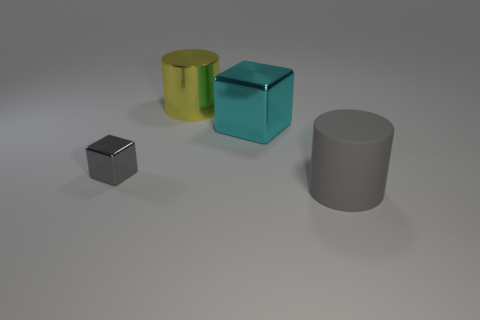Subtract all green blocks. Subtract all yellow cylinders. How many blocks are left? 2 Add 3 small purple metal spheres. How many objects exist? 7 Subtract 0 blue cylinders. How many objects are left? 4 Subtract all tiny metallic blocks. Subtract all green cylinders. How many objects are left? 3 Add 1 large matte objects. How many large matte objects are left? 2 Add 4 big gray cylinders. How many big gray cylinders exist? 5 